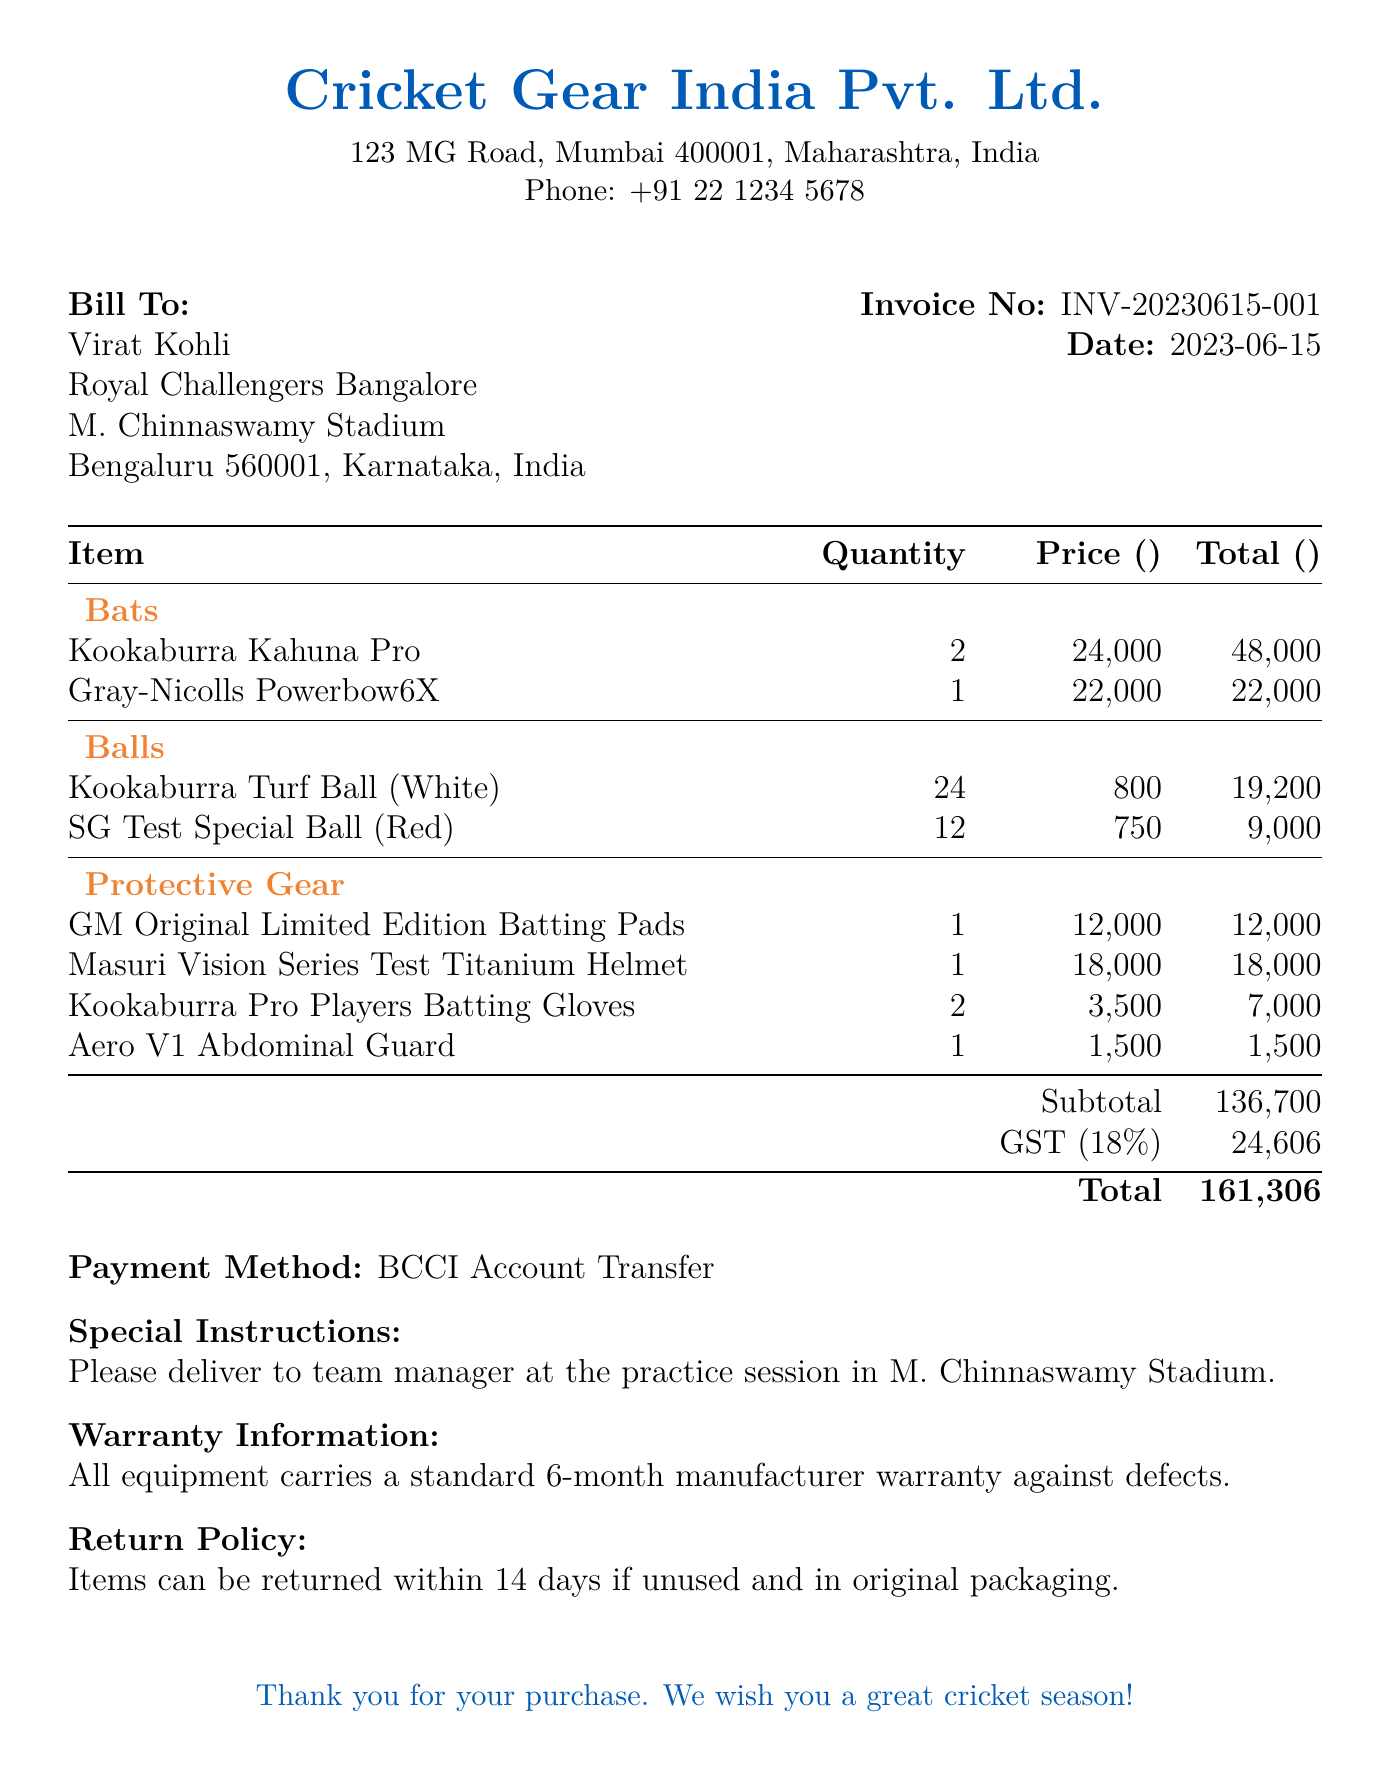What is the invoice number? The invoice number is mentioned clearly at the top of the document, identifying the transaction uniquely.
Answer: INV-20230615-001 What is the total amount payable? The total amount is calculated as the subtotal plus GST, which is stated in the invoice.
Answer: 161306 Who is the vendor? The vendor's name and contact details are provided in the document, listing the supplier of the cricket equipment.
Answer: Cricket Gear India Pvt. Ltd How many Kookaburra Kahuna Pro bats were purchased? The quantity for each item is listed, and for Kookaburra Kahuna Pro, it specifies the number acquired.
Answer: 2 What payment method was used? The document specifies the method of payment made for the purchase of equipment.
Answer: BCCI Account Transfer What is the warranty period for the equipment? The document includes warranty information, highlighting the coverage duration for the items purchased.
Answer: 6-month How many SG Test Special Balls were included in the order? The quantity of each type of ball purchased is provided in the itemized list.
Answer: 12 What special instructions were included with the order? The invoice notes specific delivery instructions which are relevant for the order's fulfillment process.
Answer: Please deliver to team manager at the practice session in M. Chinnaswamy Stadium What is the subtotal before GST? The subtotal is provided in the invoice, summarizing the total before any additional taxes are added.
Answer: 136700 